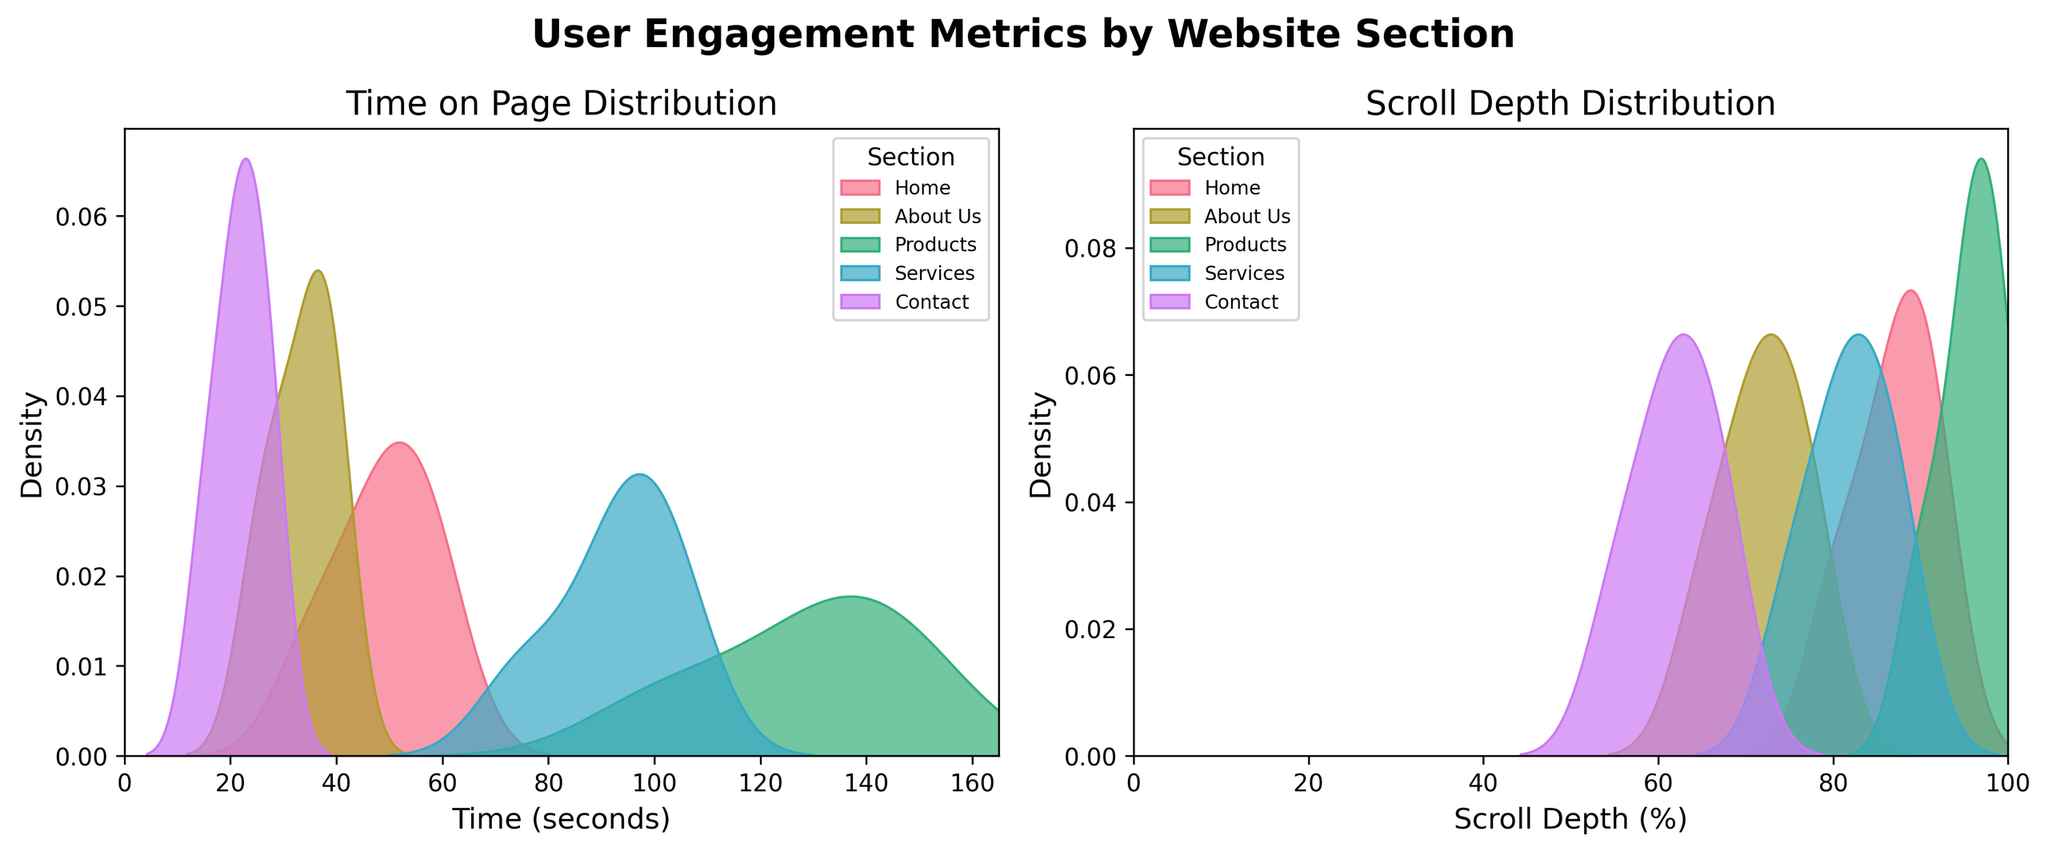what is the title of the left subplot? The title can be seen directly above the left subplot, which reads "Time on Page Distribution".
Answer: Time on Page Distribution Which section has the highest peak density for time on page? By observing the left subplot, it is visible that the "Products" section has the highest peak density among all website sections.
Answer: Products How does the scroll depth distribution for the "Contact" section compare with the "Home" section? Looking at the right subplot, the "Home" section has a higher and smoother peak density compared to the "Contact" section, indicating deeper scrolling by users on the "Home" section.
Answer: Home has deeper scrolling What is the range of the time axis for the left density plot? The x-axis of the left density plot labeled "Time (seconds)" ranges from 0 seconds to approximately 165 seconds.
Answer: 0 to 165 seconds For which section is the average time on page likely to be lowest? By examining the left subplot, the "Contact" section consistently shows lower time on page values, suggesting the average is likely the lowest.
Answer: Contact Which section shows the most variation in scroll depth? In the right subplot, the "Home" section has a wide and smooth density curve, suggesting higher variation in scroll depth compared to the other sections.
Answer: Home What can be inferred about the user engagement on the "About Us" section in terms of time on page and scroll depth? The "About Us" section has moderate peaks in both the left and right subplots, indicating average user engagement with balanced time spent on the page and decent scroll depth.
Answer: Average engagement Which website section is likely to have the deepest scroll depth on average? The right subplot indicates that the "Products" section has a high and tall peak near the 100% scroll depth mark, suggesting the deepest average scroll depth.
Answer: Products Are there any sections that have a consistent high density across both time on page and scroll depth? The "Products" section stands out in both subplots with high density peaks, indicating strong user engagement in both time on page and scroll depth.
Answer: Products 